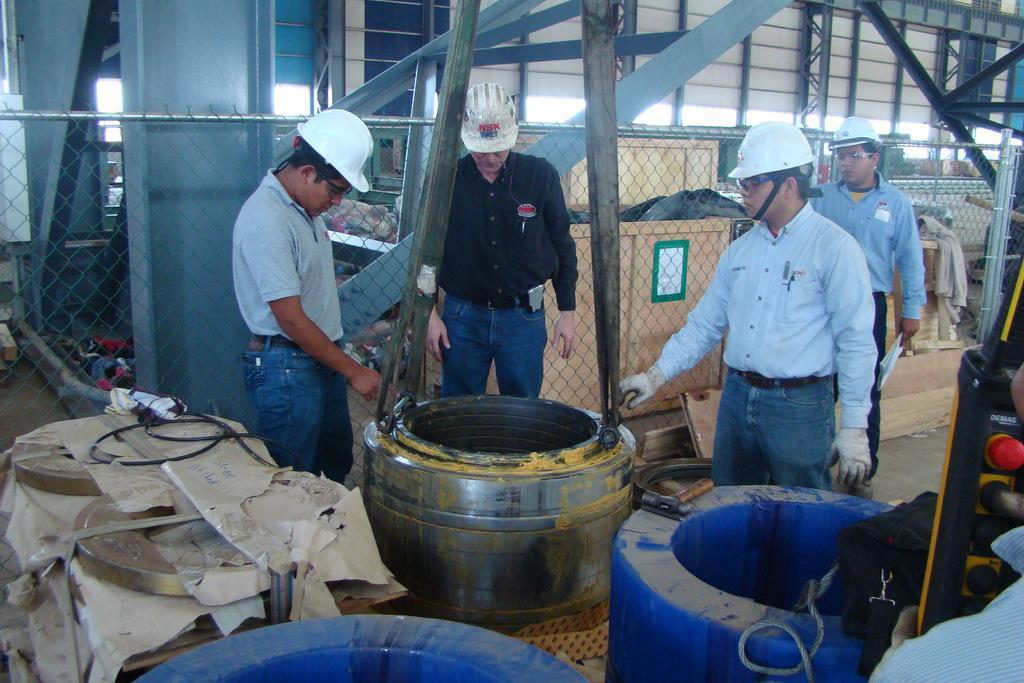Could you give a brief overview of what you see in this image? In this image I can see four persons are standing on the floor in front of boxes and vessels. In the background I can see metal rods, fence and a wall. This image is taken in a factory. 